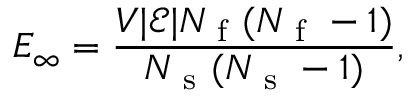<formula> <loc_0><loc_0><loc_500><loc_500>E _ { \infty } = \frac { V | \mathcal { E } | N _ { f } ( N _ { f } - 1 ) } { N _ { s } ( N _ { s } - 1 ) } ,</formula> 